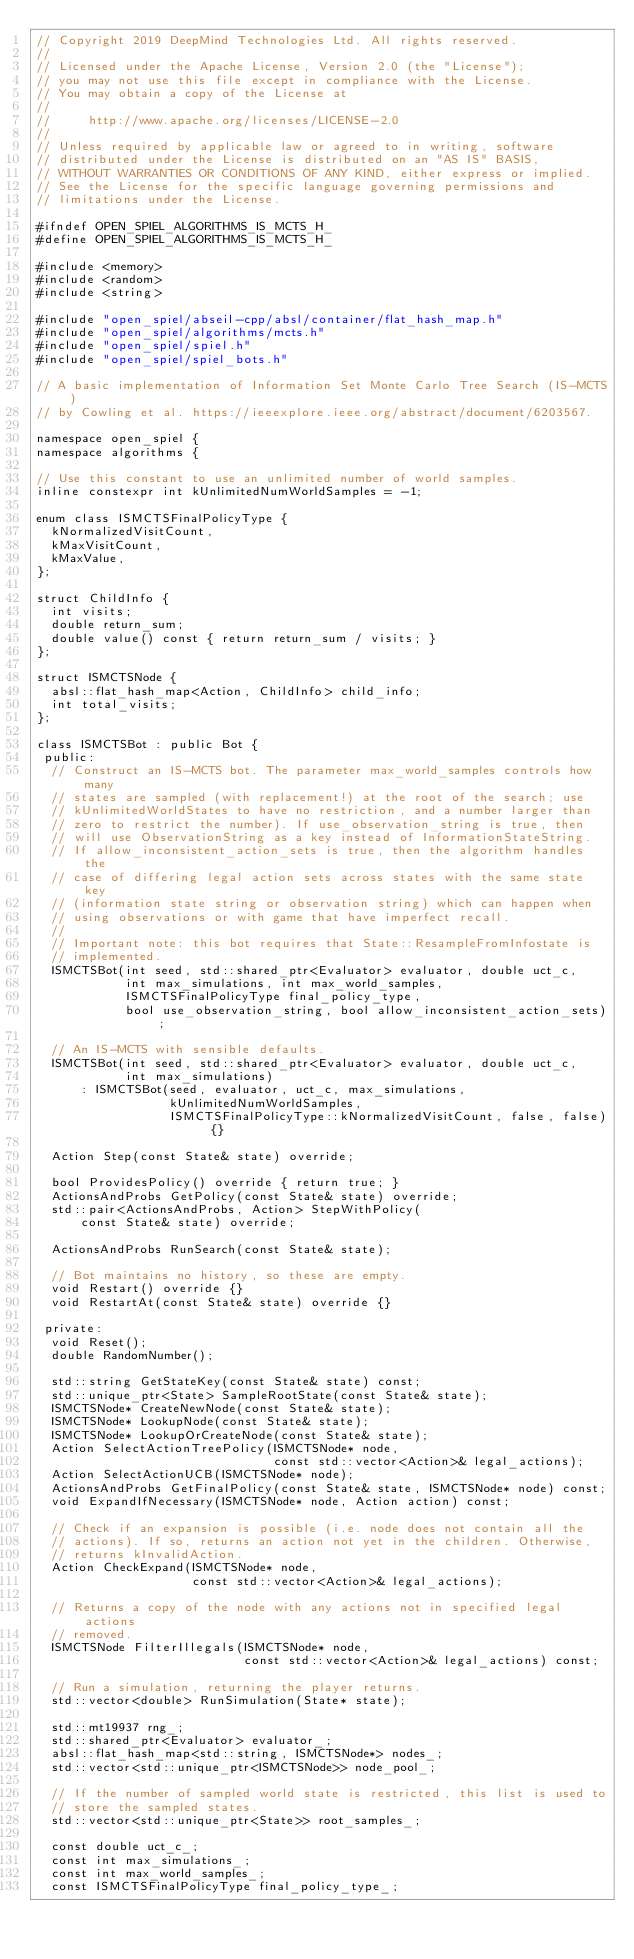Convert code to text. <code><loc_0><loc_0><loc_500><loc_500><_C_>// Copyright 2019 DeepMind Technologies Ltd. All rights reserved.
//
// Licensed under the Apache License, Version 2.0 (the "License");
// you may not use this file except in compliance with the License.
// You may obtain a copy of the License at
//
//     http://www.apache.org/licenses/LICENSE-2.0
//
// Unless required by applicable law or agreed to in writing, software
// distributed under the License is distributed on an "AS IS" BASIS,
// WITHOUT WARRANTIES OR CONDITIONS OF ANY KIND, either express or implied.
// See the License for the specific language governing permissions and
// limitations under the License.

#ifndef OPEN_SPIEL_ALGORITHMS_IS_MCTS_H_
#define OPEN_SPIEL_ALGORITHMS_IS_MCTS_H_

#include <memory>
#include <random>
#include <string>

#include "open_spiel/abseil-cpp/absl/container/flat_hash_map.h"
#include "open_spiel/algorithms/mcts.h"
#include "open_spiel/spiel.h"
#include "open_spiel/spiel_bots.h"

// A basic implementation of Information Set Monte Carlo Tree Search (IS-MCTS)
// by Cowling et al. https://ieeexplore.ieee.org/abstract/document/6203567.

namespace open_spiel {
namespace algorithms {

// Use this constant to use an unlimited number of world samples.
inline constexpr int kUnlimitedNumWorldSamples = -1;

enum class ISMCTSFinalPolicyType {
  kNormalizedVisitCount,
  kMaxVisitCount,
  kMaxValue,
};

struct ChildInfo {
  int visits;
  double return_sum;
  double value() const { return return_sum / visits; }
};

struct ISMCTSNode {
  absl::flat_hash_map<Action, ChildInfo> child_info;
  int total_visits;
};

class ISMCTSBot : public Bot {
 public:
  // Construct an IS-MCTS bot. The parameter max_world_samples controls how many
  // states are sampled (with replacement!) at the root of the search; use
  // kUnlimitedWorldStates to have no restriction, and a number larger than
  // zero to restrict the number). If use_observation_string is true, then
  // will use ObservationString as a key instead of InformationStateString.
  // If allow_inconsistent_action_sets is true, then the algorithm handles the
  // case of differing legal action sets across states with the same state key
  // (information state string or observation string) which can happen when
  // using observations or with game that have imperfect recall.
  //
  // Important note: this bot requires that State::ResampleFromInfostate is
  // implemented.
  ISMCTSBot(int seed, std::shared_ptr<Evaluator> evaluator, double uct_c,
            int max_simulations, int max_world_samples,
            ISMCTSFinalPolicyType final_policy_type,
            bool use_observation_string, bool allow_inconsistent_action_sets);

  // An IS-MCTS with sensible defaults.
  ISMCTSBot(int seed, std::shared_ptr<Evaluator> evaluator, double uct_c,
            int max_simulations)
      : ISMCTSBot(seed, evaluator, uct_c, max_simulations,
                  kUnlimitedNumWorldSamples,
                  ISMCTSFinalPolicyType::kNormalizedVisitCount, false, false) {}

  Action Step(const State& state) override;

  bool ProvidesPolicy() override { return true; }
  ActionsAndProbs GetPolicy(const State& state) override;
  std::pair<ActionsAndProbs, Action> StepWithPolicy(
      const State& state) override;

  ActionsAndProbs RunSearch(const State& state);

  // Bot maintains no history, so these are empty.
  void Restart() override {}
  void RestartAt(const State& state) override {}

 private:
  void Reset();
  double RandomNumber();

  std::string GetStateKey(const State& state) const;
  std::unique_ptr<State> SampleRootState(const State& state);
  ISMCTSNode* CreateNewNode(const State& state);
  ISMCTSNode* LookupNode(const State& state);
  ISMCTSNode* LookupOrCreateNode(const State& state);
  Action SelectActionTreePolicy(ISMCTSNode* node,
                                const std::vector<Action>& legal_actions);
  Action SelectActionUCB(ISMCTSNode* node);
  ActionsAndProbs GetFinalPolicy(const State& state, ISMCTSNode* node) const;
  void ExpandIfNecessary(ISMCTSNode* node, Action action) const;

  // Check if an expansion is possible (i.e. node does not contain all the
  // actions). If so, returns an action not yet in the children. Otherwise,
  // returns kInvalidAction.
  Action CheckExpand(ISMCTSNode* node,
                     const std::vector<Action>& legal_actions);

  // Returns a copy of the node with any actions not in specified legal actions
  // removed.
  ISMCTSNode FilterIllegals(ISMCTSNode* node,
                            const std::vector<Action>& legal_actions) const;

  // Run a simulation, returning the player returns.
  std::vector<double> RunSimulation(State* state);

  std::mt19937 rng_;
  std::shared_ptr<Evaluator> evaluator_;
  absl::flat_hash_map<std::string, ISMCTSNode*> nodes_;
  std::vector<std::unique_ptr<ISMCTSNode>> node_pool_;

  // If the number of sampled world state is restricted, this list is used to
  // store the sampled states.
  std::vector<std::unique_ptr<State>> root_samples_;

  const double uct_c_;
  const int max_simulations_;
  const int max_world_samples_;
  const ISMCTSFinalPolicyType final_policy_type_;</code> 